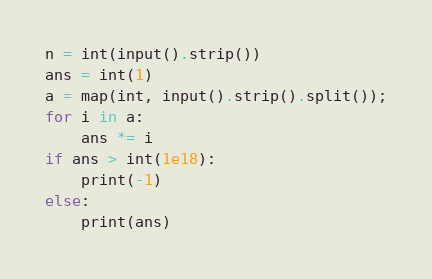<code> <loc_0><loc_0><loc_500><loc_500><_Python_>n = int(input().strip())
ans = int(1)
a = map(int, input().strip().split());
for i in a:
	ans *= i
if ans > int(1e18):
	print(-1)
else:
	print(ans)</code> 